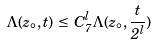<formula> <loc_0><loc_0><loc_500><loc_500>\Lambda ( z _ { \circ } , t ) \, \leq \, C _ { 7 } ^ { l } \Lambda ( z _ { \circ } , \frac { t } { 2 ^ { l } } )</formula> 